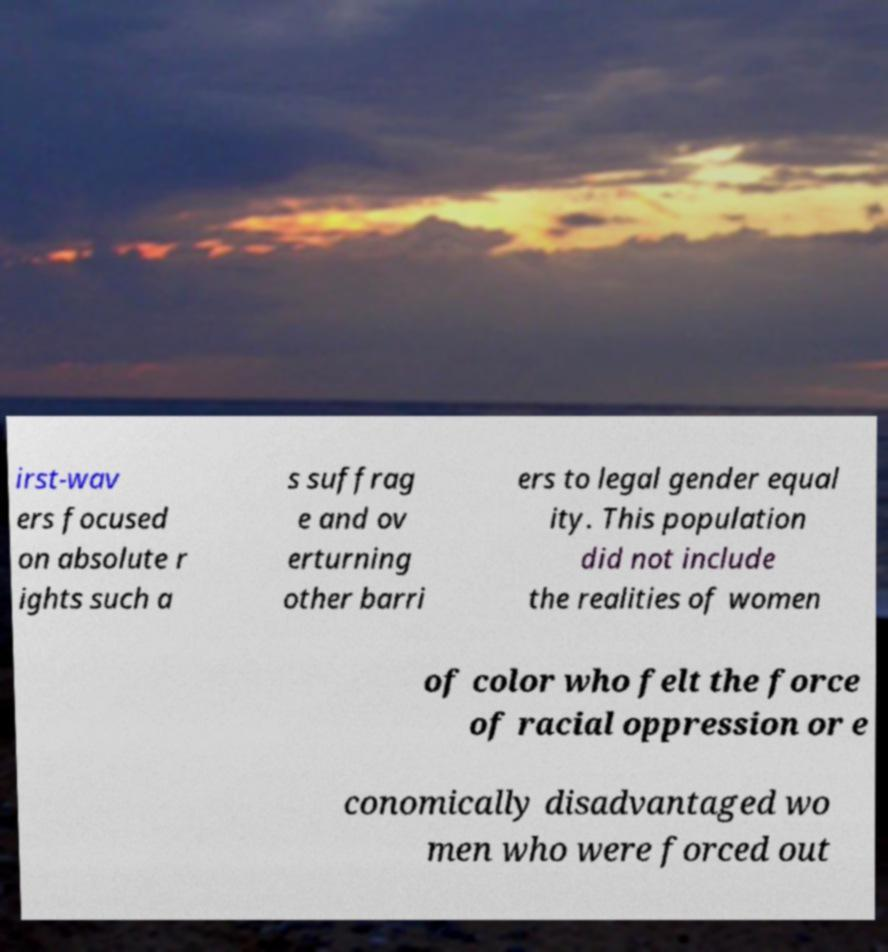Could you extract and type out the text from this image? irst-wav ers focused on absolute r ights such a s suffrag e and ov erturning other barri ers to legal gender equal ity. This population did not include the realities of women of color who felt the force of racial oppression or e conomically disadvantaged wo men who were forced out 